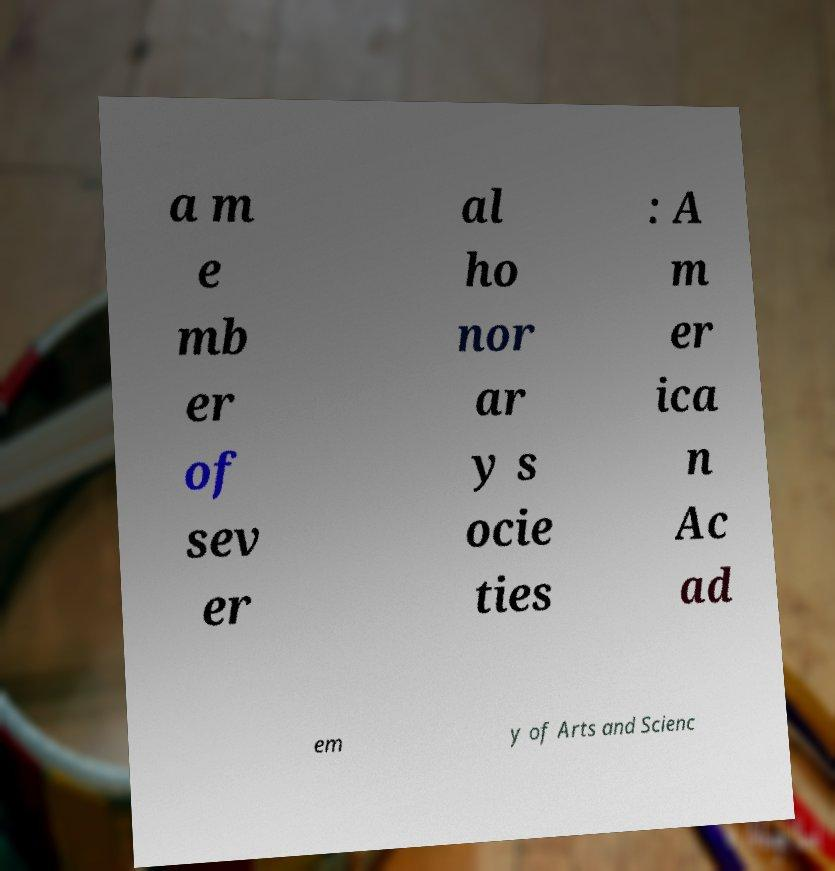Could you assist in decoding the text presented in this image and type it out clearly? a m e mb er of sev er al ho nor ar y s ocie ties : A m er ica n Ac ad em y of Arts and Scienc 